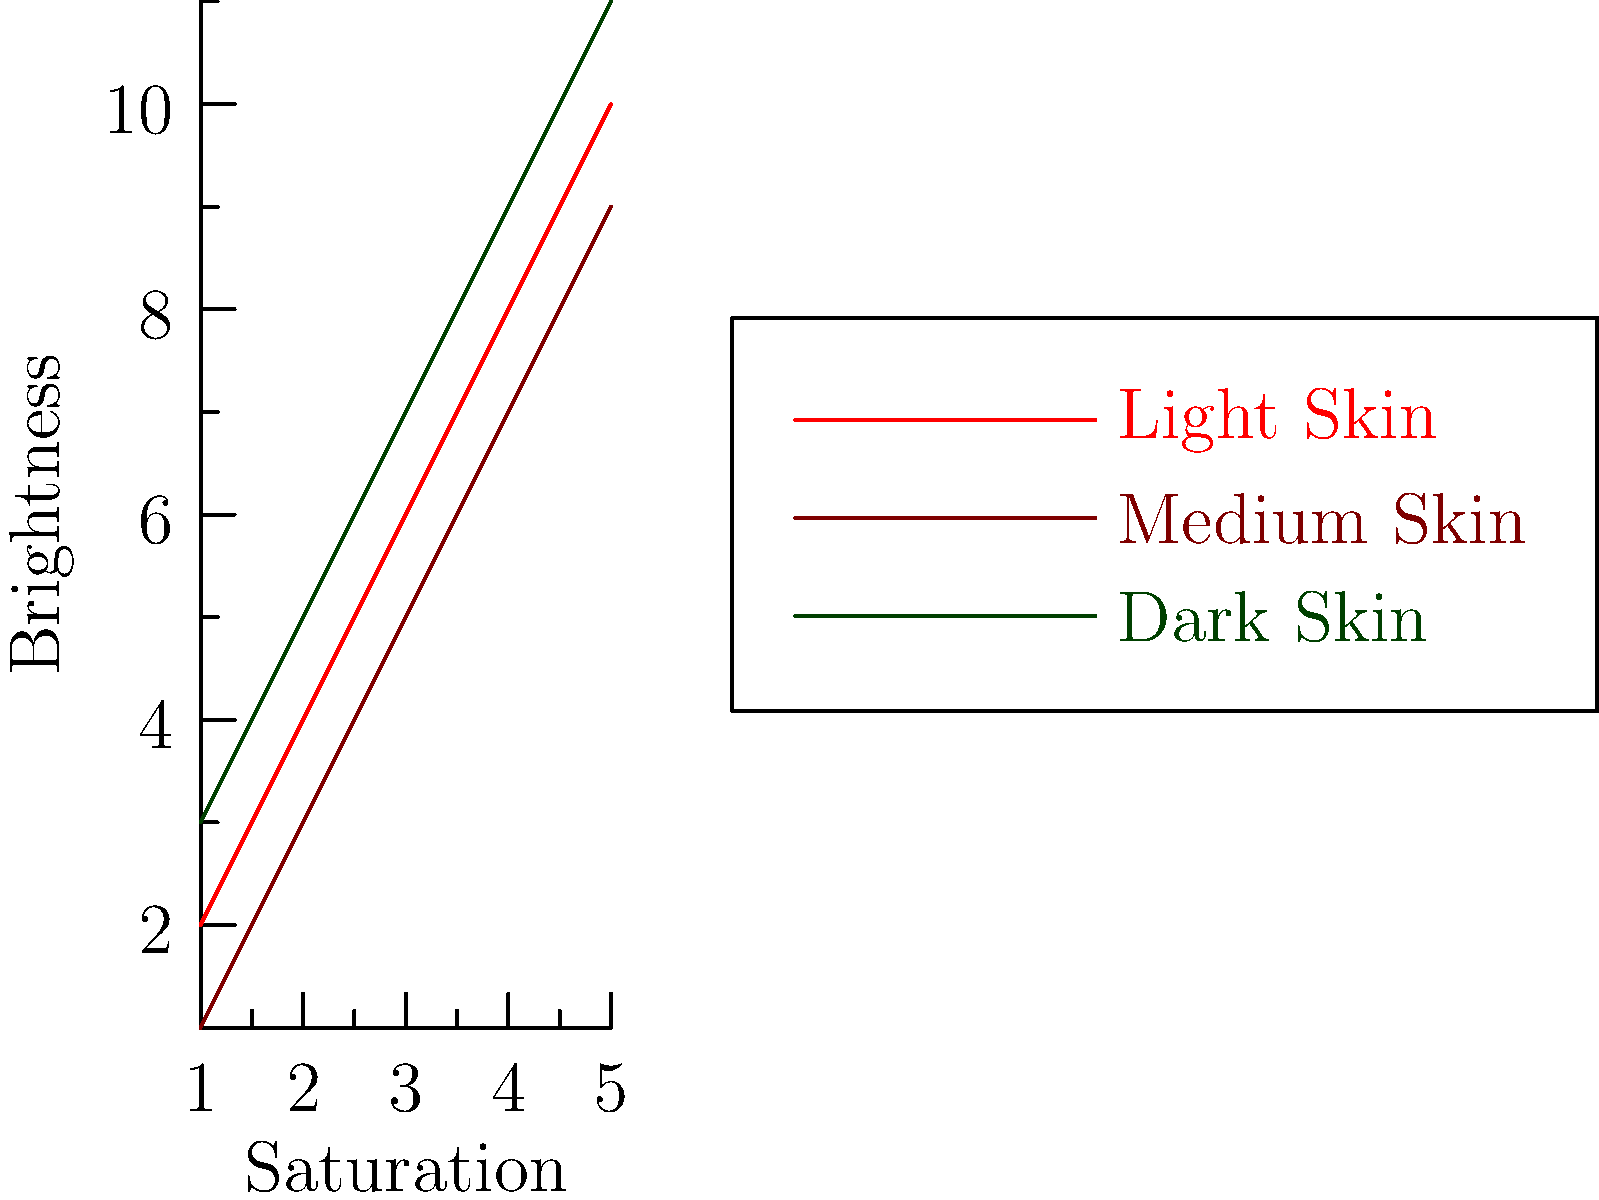As an illustrator collaborating with an author on a diverse cast of characters, you're tasked with selecting appropriate color palettes for different skin tones. Based on the graph showing the relationship between saturation and brightness for various skin tones, which skin tone category generally requires the highest brightness values for accurate representation? To answer this question, we need to analyze the graph and compare the brightness levels for each skin tone category:

1. The graph shows three lines representing different skin tone categories: Light Skin (red), Medium Skin (brown), and Dark Skin (green).

2. The x-axis represents saturation, while the y-axis represents brightness.

3. We need to compare the y-values (brightness) for each line at corresponding x-values (saturation levels).

4. Observing the graph, we can see that:
   - The green line (Dark Skin) consistently has the highest y-values.
   - The red line (Light Skin) is in the middle.
   - The brown line (Medium Skin) has the lowest y-values.

5. This means that for any given saturation level, the Dark Skin category requires higher brightness values compared to Medium and Light Skin categories.

6. The higher brightness for darker skin tones is necessary to accurately represent the depth and richness of these skin colors, avoiding a flat or dull appearance in illustrations.

Therefore, based on this graph, the Dark Skin category generally requires the highest brightness values for accurate representation in illustrations.
Answer: Dark Skin 